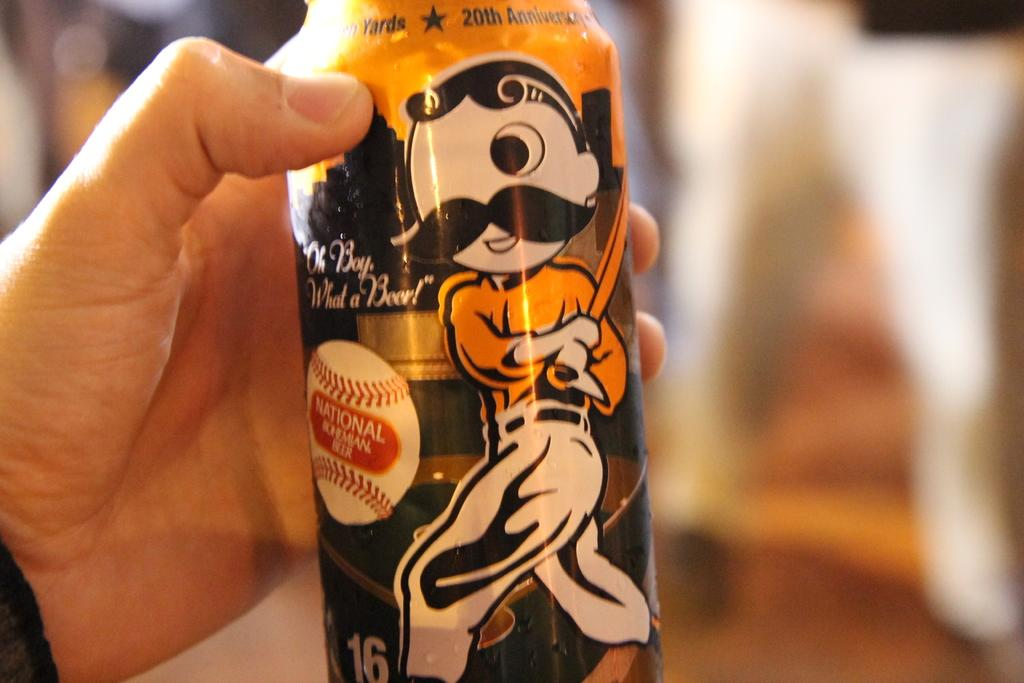<image>
Relay a brief, clear account of the picture shown. a can that says national on the front of it 